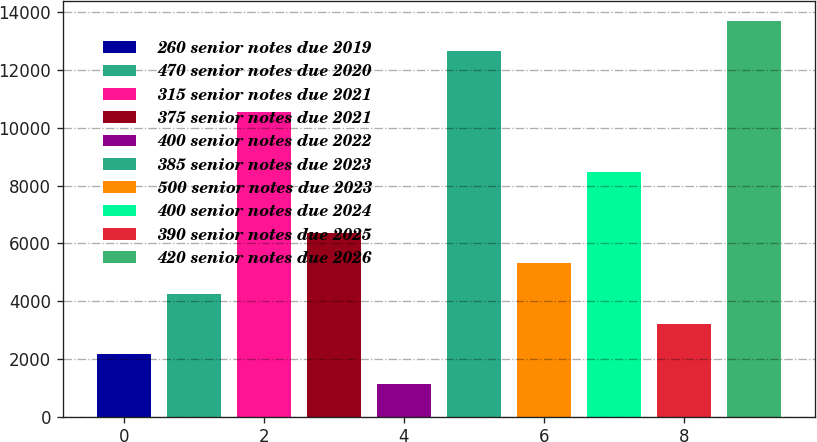Convert chart. <chart><loc_0><loc_0><loc_500><loc_500><bar_chart><fcel>260 senior notes due 2019<fcel>470 senior notes due 2020<fcel>315 senior notes due 2021<fcel>375 senior notes due 2021<fcel>400 senior notes due 2022<fcel>385 senior notes due 2023<fcel>500 senior notes due 2023<fcel>400 senior notes due 2024<fcel>390 senior notes due 2025<fcel>420 senior notes due 2026<nl><fcel>2166.68<fcel>4262.76<fcel>10551<fcel>6358.84<fcel>1118.64<fcel>12647.1<fcel>5310.8<fcel>8454.92<fcel>3214.72<fcel>13695.1<nl></chart> 